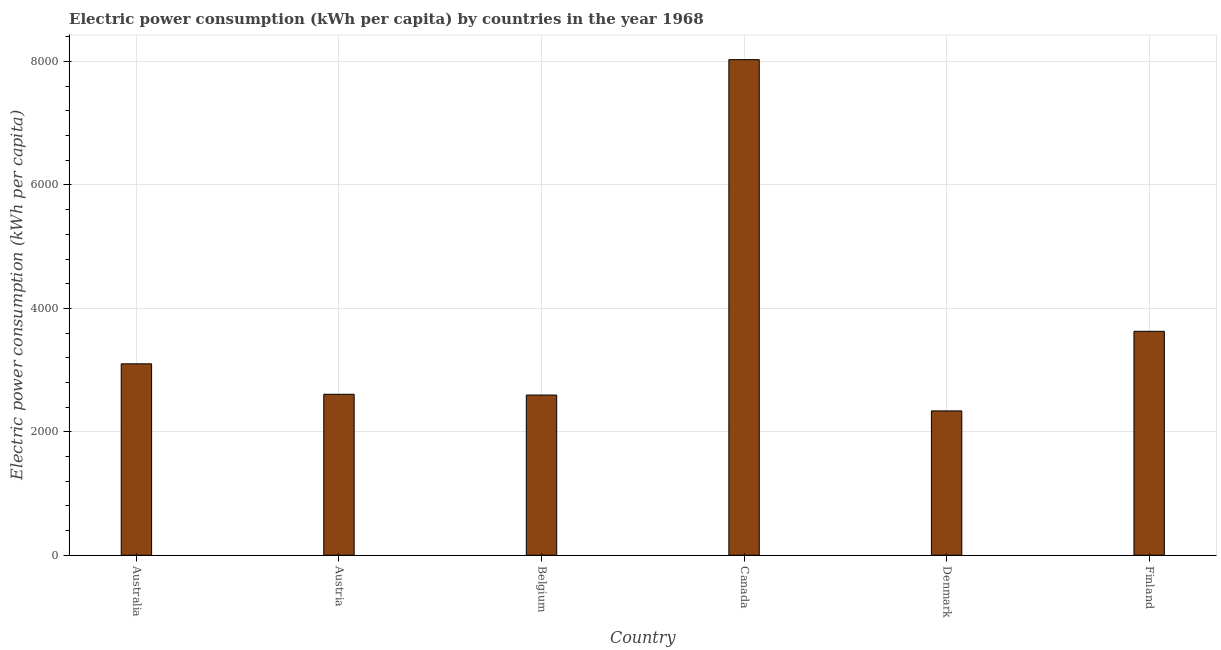Does the graph contain any zero values?
Provide a succinct answer. No. What is the title of the graph?
Give a very brief answer. Electric power consumption (kWh per capita) by countries in the year 1968. What is the label or title of the X-axis?
Make the answer very short. Country. What is the label or title of the Y-axis?
Your answer should be compact. Electric power consumption (kWh per capita). What is the electric power consumption in Belgium?
Offer a terse response. 2596.18. Across all countries, what is the maximum electric power consumption?
Offer a terse response. 8030.42. Across all countries, what is the minimum electric power consumption?
Provide a short and direct response. 2339.21. What is the sum of the electric power consumption?
Your answer should be very brief. 2.23e+04. What is the difference between the electric power consumption in Belgium and Denmark?
Your answer should be compact. 256.96. What is the average electric power consumption per country?
Your response must be concise. 3717.52. What is the median electric power consumption?
Your answer should be compact. 2855.32. What is the ratio of the electric power consumption in Denmark to that in Finland?
Ensure brevity in your answer.  0.65. Is the electric power consumption in Austria less than that in Denmark?
Your answer should be compact. No. What is the difference between the highest and the second highest electric power consumption?
Provide a succinct answer. 4401.73. What is the difference between the highest and the lowest electric power consumption?
Your response must be concise. 5691.2. How many bars are there?
Your response must be concise. 6. What is the difference between two consecutive major ticks on the Y-axis?
Your answer should be very brief. 2000. What is the Electric power consumption (kWh per capita) in Australia?
Your response must be concise. 3102.01. What is the Electric power consumption (kWh per capita) of Austria?
Your answer should be very brief. 2608.62. What is the Electric power consumption (kWh per capita) of Belgium?
Keep it short and to the point. 2596.18. What is the Electric power consumption (kWh per capita) of Canada?
Ensure brevity in your answer.  8030.42. What is the Electric power consumption (kWh per capita) of Denmark?
Give a very brief answer. 2339.21. What is the Electric power consumption (kWh per capita) of Finland?
Give a very brief answer. 3628.69. What is the difference between the Electric power consumption (kWh per capita) in Australia and Austria?
Keep it short and to the point. 493.38. What is the difference between the Electric power consumption (kWh per capita) in Australia and Belgium?
Keep it short and to the point. 505.83. What is the difference between the Electric power consumption (kWh per capita) in Australia and Canada?
Your response must be concise. -4928.41. What is the difference between the Electric power consumption (kWh per capita) in Australia and Denmark?
Make the answer very short. 762.79. What is the difference between the Electric power consumption (kWh per capita) in Australia and Finland?
Keep it short and to the point. -526.68. What is the difference between the Electric power consumption (kWh per capita) in Austria and Belgium?
Your answer should be compact. 12.45. What is the difference between the Electric power consumption (kWh per capita) in Austria and Canada?
Offer a very short reply. -5421.79. What is the difference between the Electric power consumption (kWh per capita) in Austria and Denmark?
Keep it short and to the point. 269.41. What is the difference between the Electric power consumption (kWh per capita) in Austria and Finland?
Ensure brevity in your answer.  -1020.06. What is the difference between the Electric power consumption (kWh per capita) in Belgium and Canada?
Your response must be concise. -5434.24. What is the difference between the Electric power consumption (kWh per capita) in Belgium and Denmark?
Provide a short and direct response. 256.96. What is the difference between the Electric power consumption (kWh per capita) in Belgium and Finland?
Your answer should be very brief. -1032.51. What is the difference between the Electric power consumption (kWh per capita) in Canada and Denmark?
Give a very brief answer. 5691.2. What is the difference between the Electric power consumption (kWh per capita) in Canada and Finland?
Offer a very short reply. 4401.73. What is the difference between the Electric power consumption (kWh per capita) in Denmark and Finland?
Offer a very short reply. -1289.47. What is the ratio of the Electric power consumption (kWh per capita) in Australia to that in Austria?
Ensure brevity in your answer.  1.19. What is the ratio of the Electric power consumption (kWh per capita) in Australia to that in Belgium?
Keep it short and to the point. 1.2. What is the ratio of the Electric power consumption (kWh per capita) in Australia to that in Canada?
Give a very brief answer. 0.39. What is the ratio of the Electric power consumption (kWh per capita) in Australia to that in Denmark?
Your answer should be compact. 1.33. What is the ratio of the Electric power consumption (kWh per capita) in Australia to that in Finland?
Offer a very short reply. 0.85. What is the ratio of the Electric power consumption (kWh per capita) in Austria to that in Canada?
Keep it short and to the point. 0.33. What is the ratio of the Electric power consumption (kWh per capita) in Austria to that in Denmark?
Offer a terse response. 1.11. What is the ratio of the Electric power consumption (kWh per capita) in Austria to that in Finland?
Make the answer very short. 0.72. What is the ratio of the Electric power consumption (kWh per capita) in Belgium to that in Canada?
Ensure brevity in your answer.  0.32. What is the ratio of the Electric power consumption (kWh per capita) in Belgium to that in Denmark?
Offer a terse response. 1.11. What is the ratio of the Electric power consumption (kWh per capita) in Belgium to that in Finland?
Give a very brief answer. 0.71. What is the ratio of the Electric power consumption (kWh per capita) in Canada to that in Denmark?
Give a very brief answer. 3.43. What is the ratio of the Electric power consumption (kWh per capita) in Canada to that in Finland?
Give a very brief answer. 2.21. What is the ratio of the Electric power consumption (kWh per capita) in Denmark to that in Finland?
Make the answer very short. 0.65. 